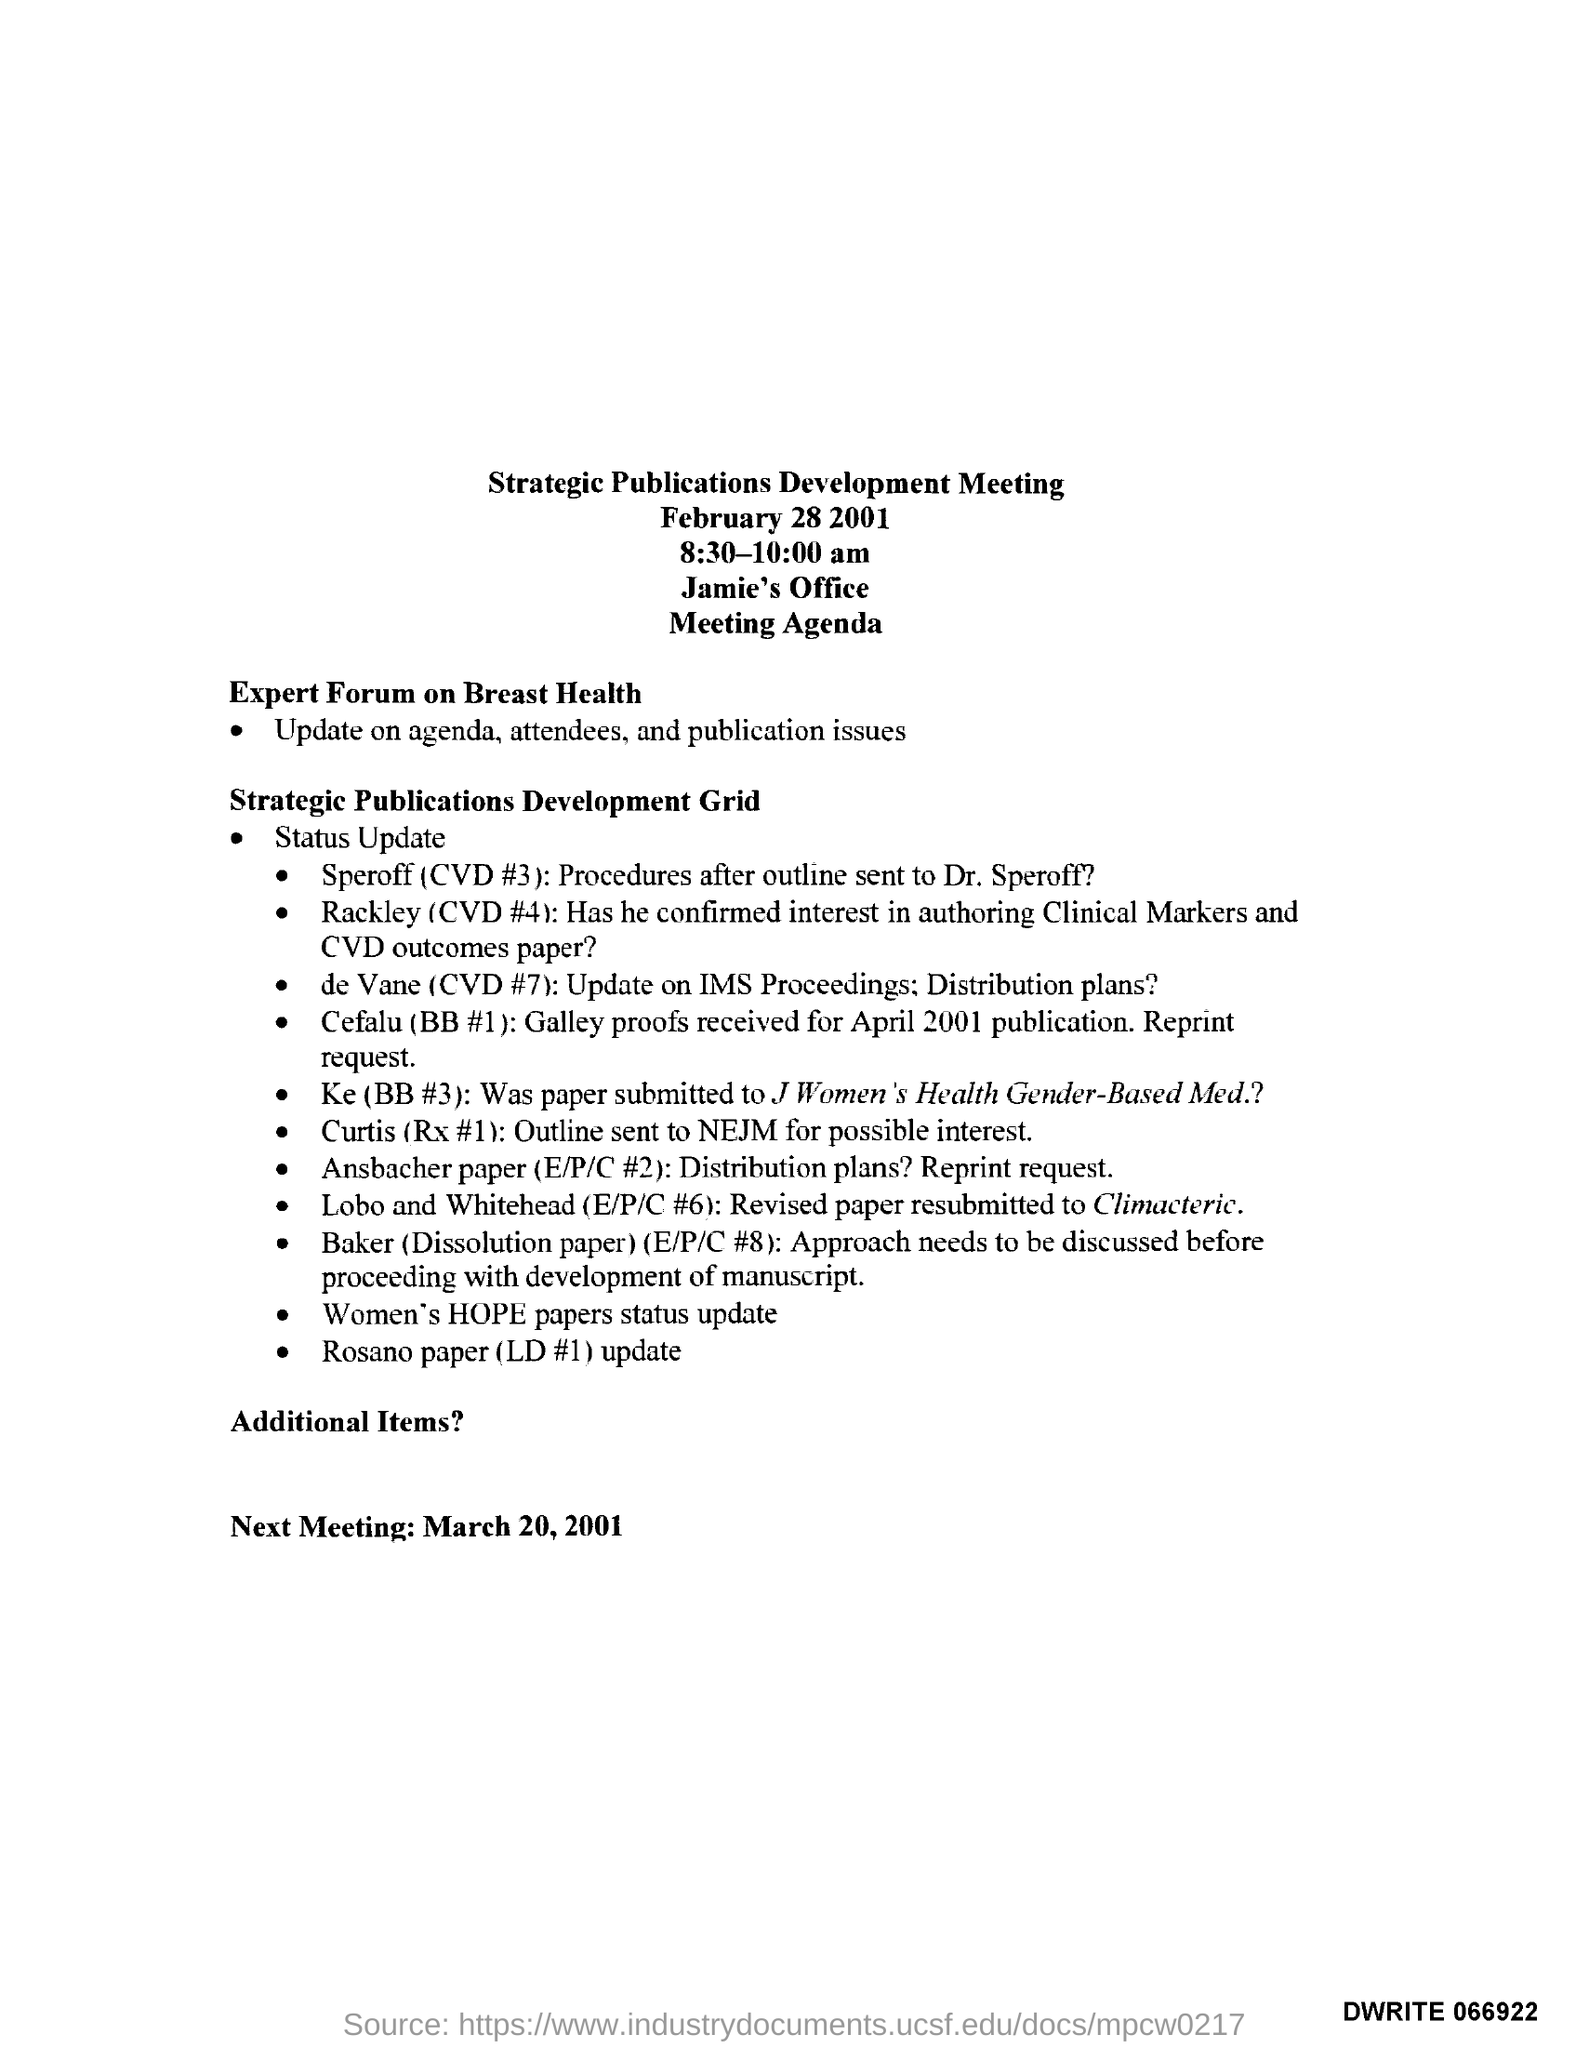Give some essential details in this illustration. The Expert Forum on Breast Health has provided an update on its agenda, attendees, and publication issues. The Strategic Publications Development Meeting is held on February 28, 2001. The Strategic Publications Development Meeting is scheduled to take place from 8:30-10:00 am. The next meeting is scheduled for March 20, 2001, as per the agenda. The Strategic Publications Development Meeting will be held at Jamie's Office. 